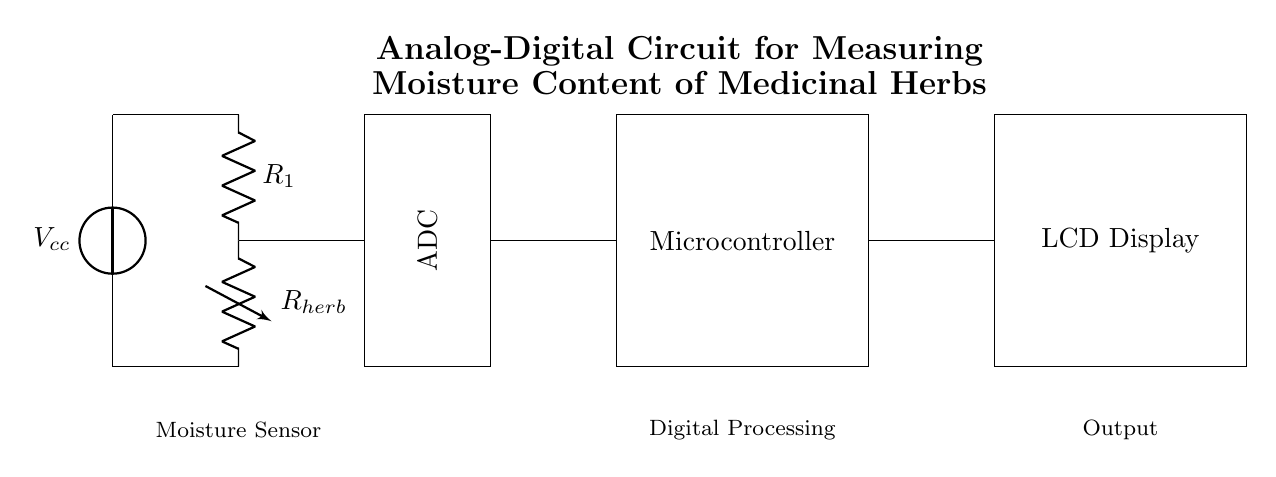What is the value of Vcc in the circuit? The voltage source, labeled as Vcc, indicates the power supply for the circuit, but the specific value is not provided in the diagram. However, typically, it may be around 5 volts or 9 volts generally used in these applications.
Answer: Vcc What component is used to measure the moisture content? The moisture sensor is represented by the variable resistor labeled as R_herb. This is the component that changes resistance based on the moisture level in the medicinal herbs.
Answer: R_herb What is the function of the ADC in this circuit? The Analog to Digital Converter (ADC) takes the analog voltage signal generated by the moisture sensor and converts it into a digital signal that can be processed by the microcontroller. This is a critical step for digital measurement and display.
Answer: Conversion What do R1 and R_herb form together? R1 and R_herb are connected in series as part of a voltage divider configuration, which is often used to measure the voltage across the moisture sensor to determine the moisture content indirectly based on resistance changes.
Answer: Voltage divider How does the moisture sensor affect the output values? As the moisture content in the herbs changes, the resistance of R_herb changes, which affects the voltage drop across it according to Ohm's law. This change in voltage is then interpreted by the ADC, influencing the final displayed value on the LCD output. It illustrates the indirect relationship between moisture content and output.
Answer: Changes voltage 